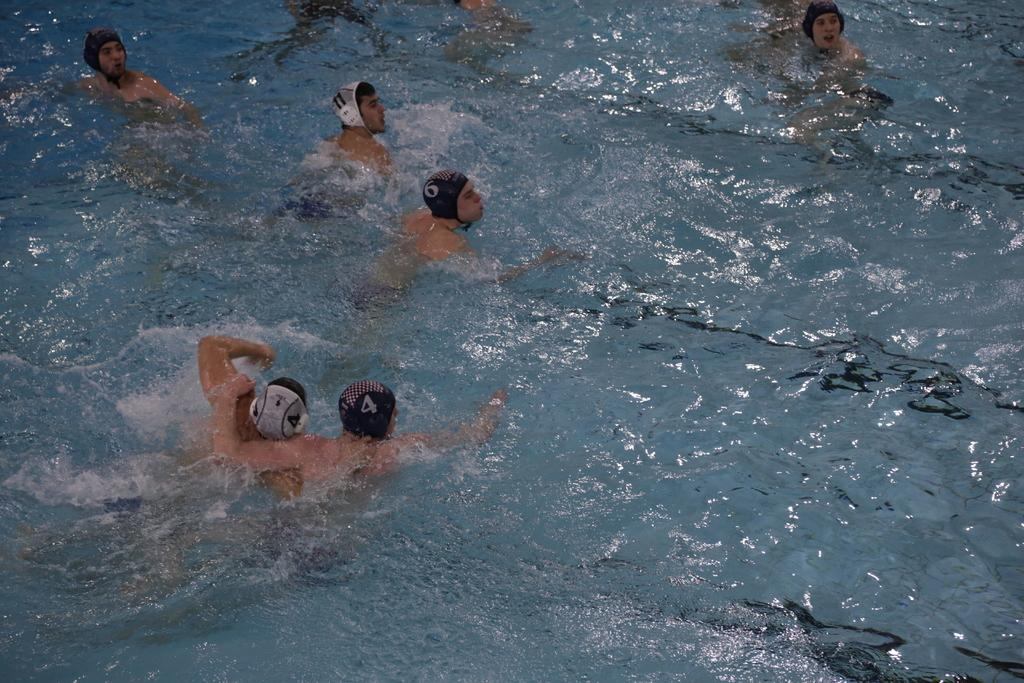What are the people in the image doing? The people in the image are in the water. What can be observed on the surface of the water? There are reflections on the water. How many cherries can be seen on the window in the image? There is no window or cherries present in the image. What type of bears are visible in the water in the image? There are no bears present in the image; it features people in the water. 